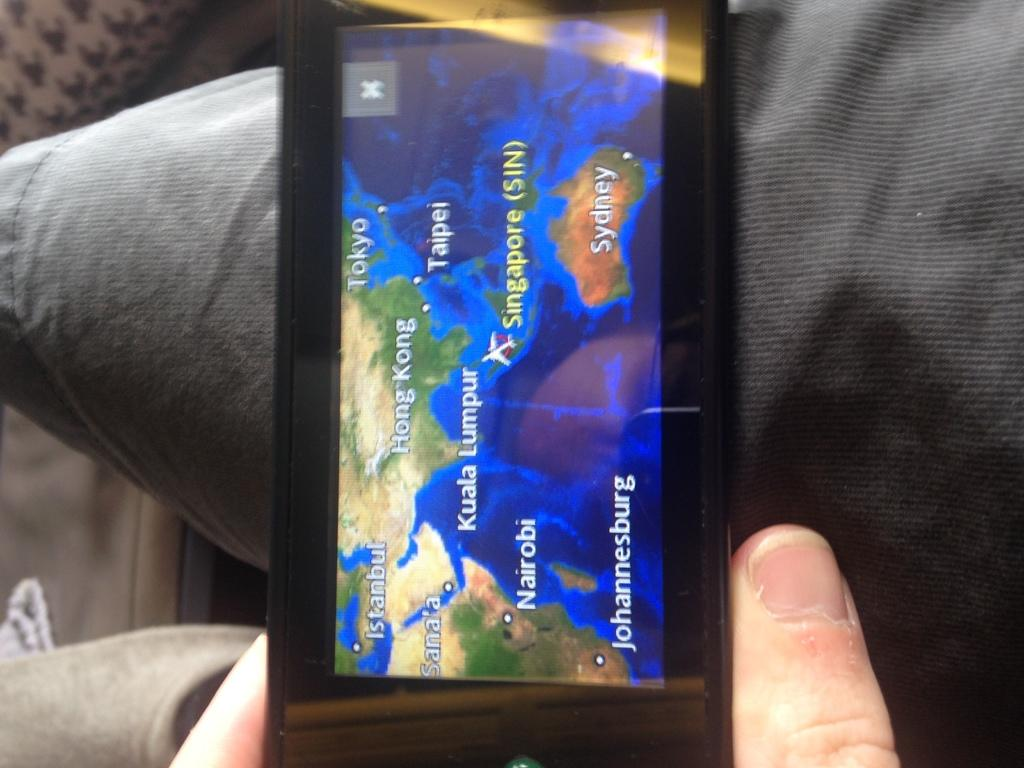<image>
Write a terse but informative summary of the picture. A person is holding a gps showing a map of Hong Kong. 